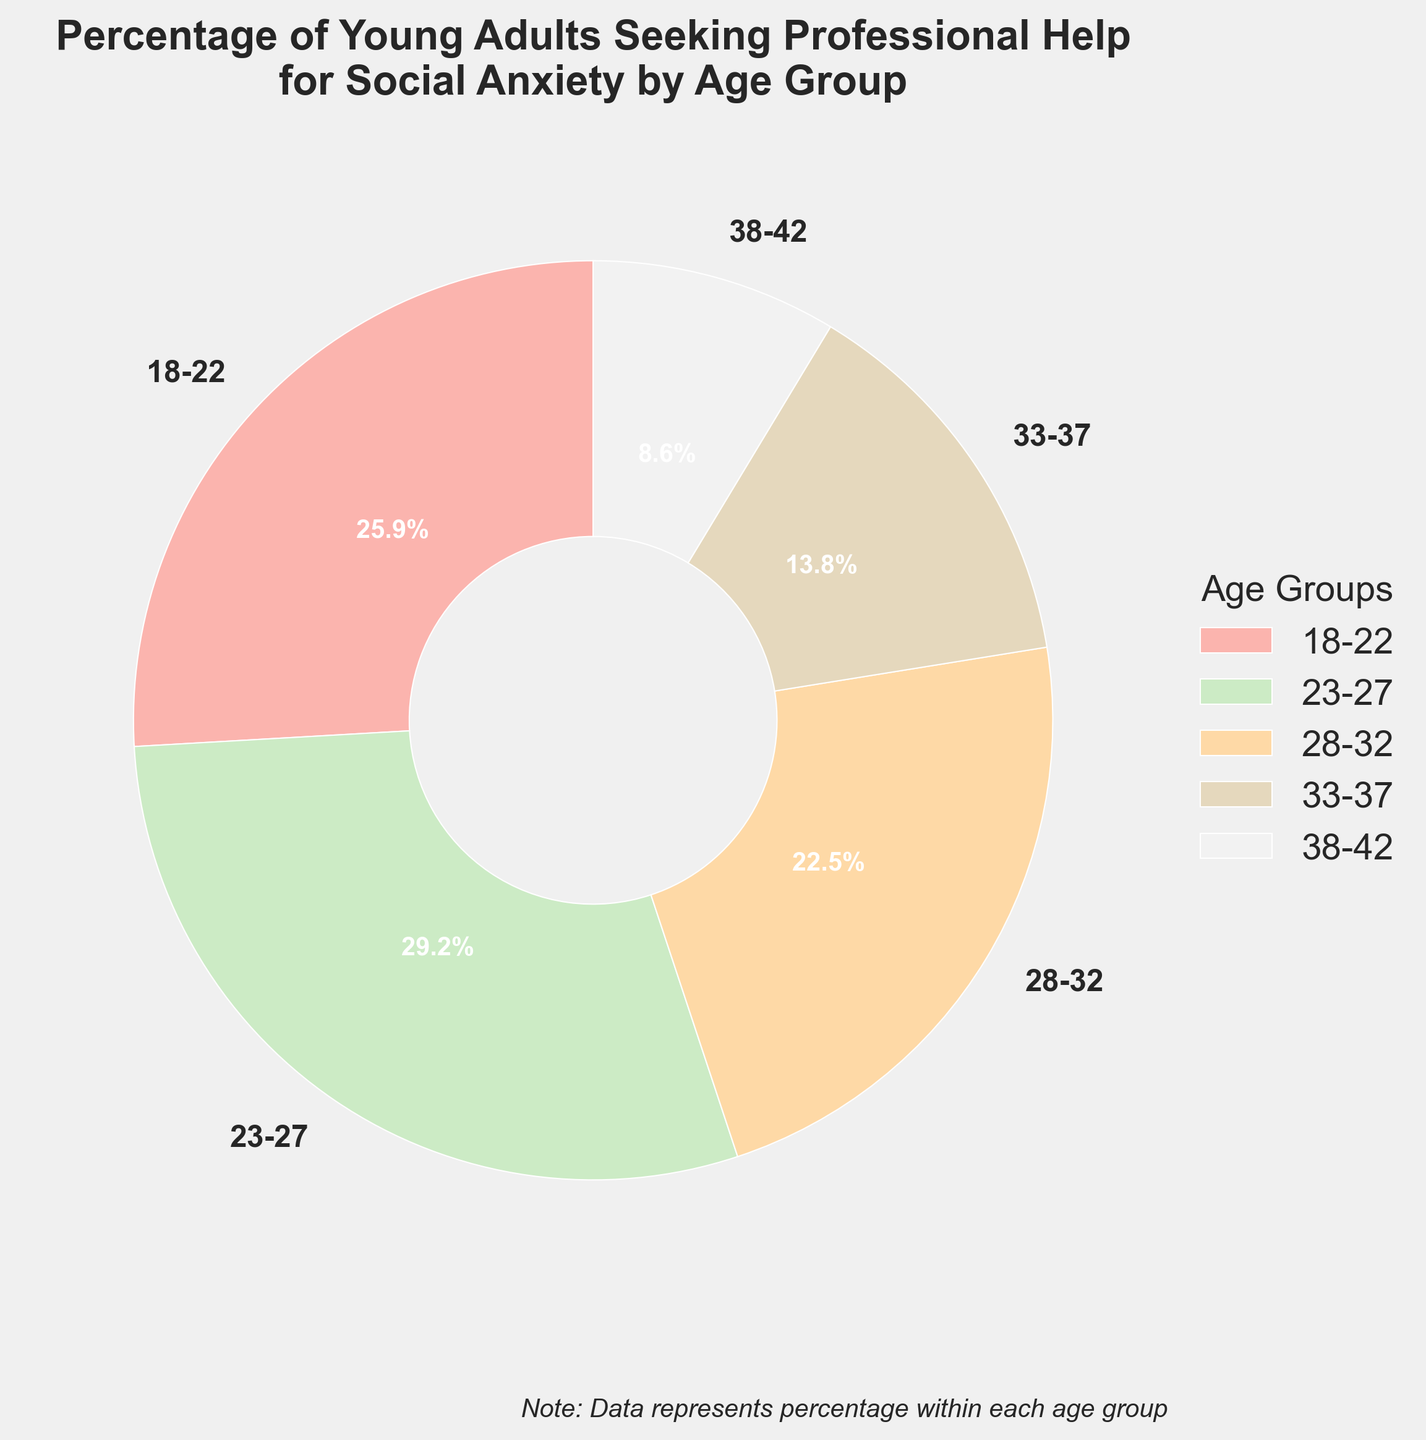What age group has the highest percentage of young adults seeking professional help for social anxiety? From the pie chart, the age group with the highest percentage can be seen directly from the labeled values. The percentage for the 23-27 age group is 32.1%.
Answer: 23-27 What is the combined percentage of young adults aged 18-22 and 23-27 seeking professional help for social anxiety? Sum the percentages of the 18-22 and 23-27 age groups. For the 18-22 age group, it is 28.5%, and for the 23-27 age group, it is 32.1%. Adding them together: 28.5% + 32.1% = 60.6%.
Answer: 60.6% Which age group has the smallest proportion of young adults seeking professional help for social anxiety? The smallest percentage on the pie chart corresponds to the 38-42 age group, which is 9.5%.
Answer: 38-42 What is the difference in percentage between the age group 23-27 and the age group 28-32? To find the difference, subtract the percentage of the 28-32 age group from the percentage of the 23-27 age group: 32.1% - 24.7% = 7.4%.
Answer: 7.4% What is the average percentage of young adults seeking professional help for social anxiety across all age groups? Calculate the average by summing all the percentages and dividing by the number of age groups. The sum of the percentages is 28.5% + 32.1% + 24.7% + 15.2% + 9.5% = 110%. There are 5 age groups, so the average is 110% / 5 = 22%.
Answer: 22% Which two consecutive age groups combined make up approximately half of the total percentage? We need to find two age groups whose combined percentage is approximately 50%. By looking at the chart, the 18-22 and 23-27 age groups' combined percentage is 28.5% + 32.1% = 60.6%, which is more than half. The 23-27 and 28-32 age groups' combined percentage is 32.1% + 24.7% = 56.8%, which is slightly more than half. None of the other combinations give a value close to 50%. So, the closest is 23-27 and 28-32.
Answer: 23-27 and 28-32 What is the median percentage for the different age groups? The median is the middle value when the percentages are arranged in ascending order. Ordering them: 9.5%, 15.2%, 24.7%, 28.5%, 32.1%. The middle value is 24.7%.
Answer: 24.7% How much higher is the percentage for the 18-22 age group than the percentage for the 38-42 age group? Subtract the percentage of the 38-42 age group from the percentage of the 18-22 age group: 28.5% - 9.5% = 19%.
Answer: 19% What visual attribute differentiates the segment for the 23-27 group compared to the other segments? The pie chart uses colors to differentiate segments. The segment for the 23-27 age group is distinctly colored within the given palette, making it visually distinguishable. Without the exact color code, it is a unique color distinct from the others in the chart.
Answer: Unique color within the palette 